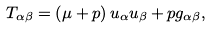<formula> <loc_0><loc_0><loc_500><loc_500>T _ { \alpha \beta } = \left ( \mu + p \right ) u _ { \alpha } u _ { \beta } + p g _ { \alpha \beta } ,</formula> 